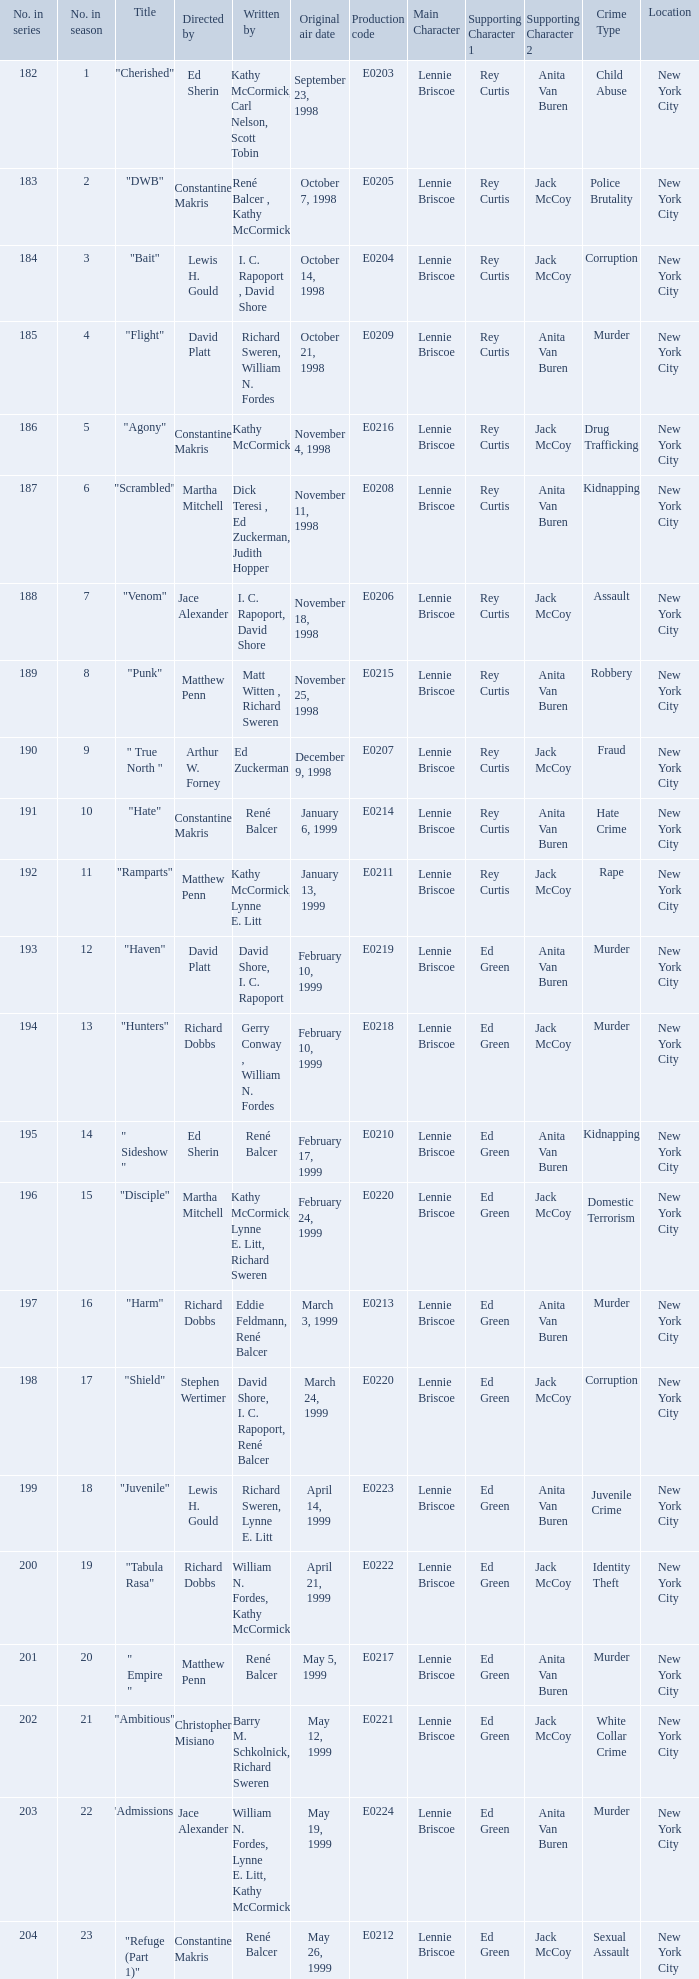What is the title of the episode with the original air date October 21, 1998? "Flight". 